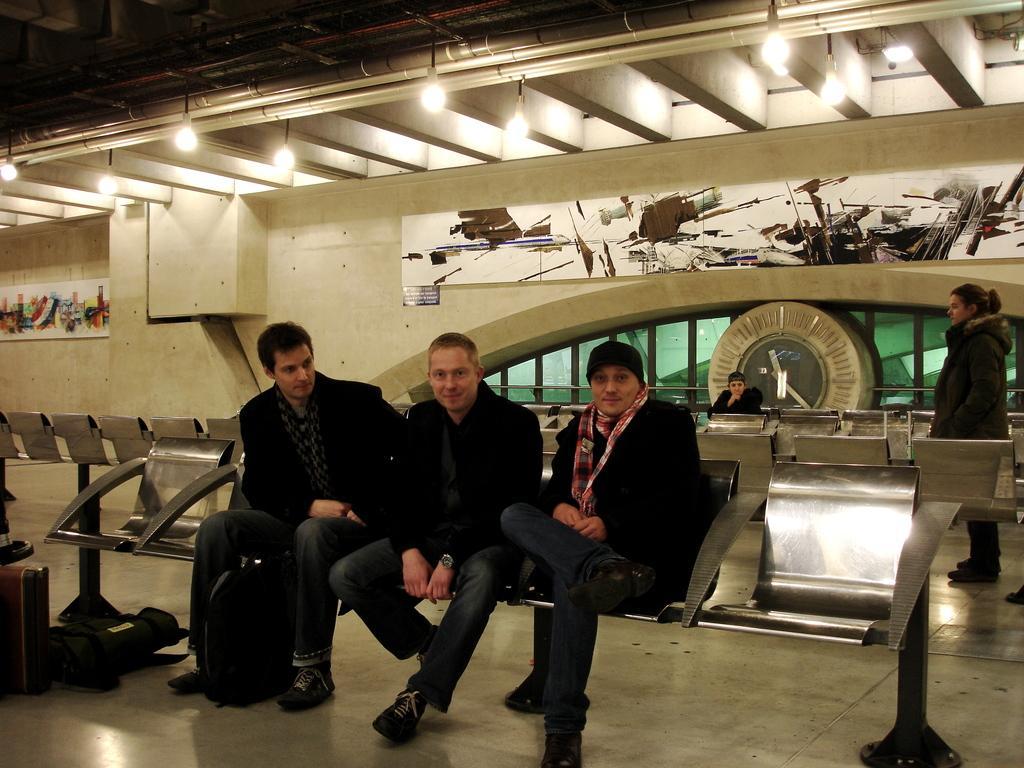Could you give a brief overview of what you see in this image? In this image in the foreground there are three people sitting on chairs, and there are some luggage and in the background there are some chairs and one person is sitting and one person is standing. And there is a wall, on the wall there are some boards. On the boards there are some images, and at the bottom there is floor and at the top there is ceiling, pipes and some lights. And in the background there is a clock and glass windows. 